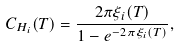<formula> <loc_0><loc_0><loc_500><loc_500>C _ { H _ { i } } ( T ) = \frac { 2 \pi \xi _ { i } ( T ) } { 1 - e ^ { - 2 \pi \xi _ { i } ( T ) } } ,</formula> 